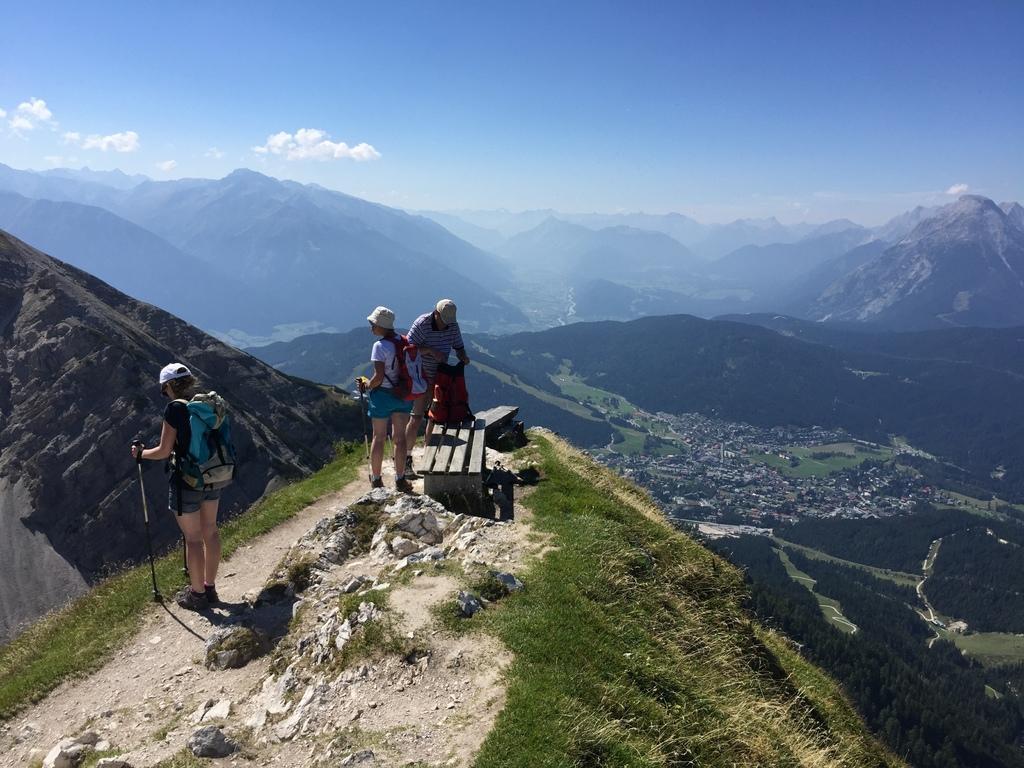Describe this image in one or two sentences. In this image there are two people holding the sticks. Behind them there is another person holding the bag. There is a bench. At the bottom of the image there are rocks and grass on the surface. In the background of the image there are trees, buildings and mountains. At the top of the image there are clouds in the sky. 